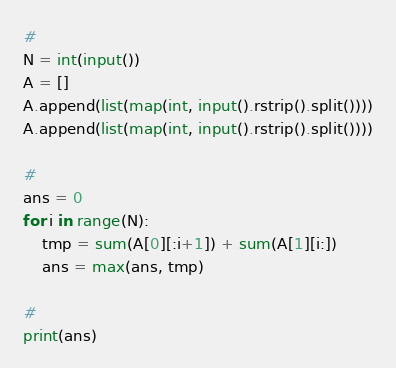<code> <loc_0><loc_0><loc_500><loc_500><_Python_>#
N = int(input())
A = []
A.append(list(map(int, input().rstrip().split())))
A.append(list(map(int, input().rstrip().split())))

#
ans = 0
for i in range(N):
    tmp = sum(A[0][:i+1]) + sum(A[1][i:])
    ans = max(ans, tmp)

#
print(ans)
</code> 